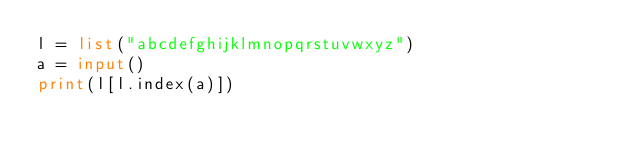Convert code to text. <code><loc_0><loc_0><loc_500><loc_500><_Python_>l = list("abcdefghijklmnopqrstuvwxyz")
a = input()
print(l[l.index(a)])
</code> 